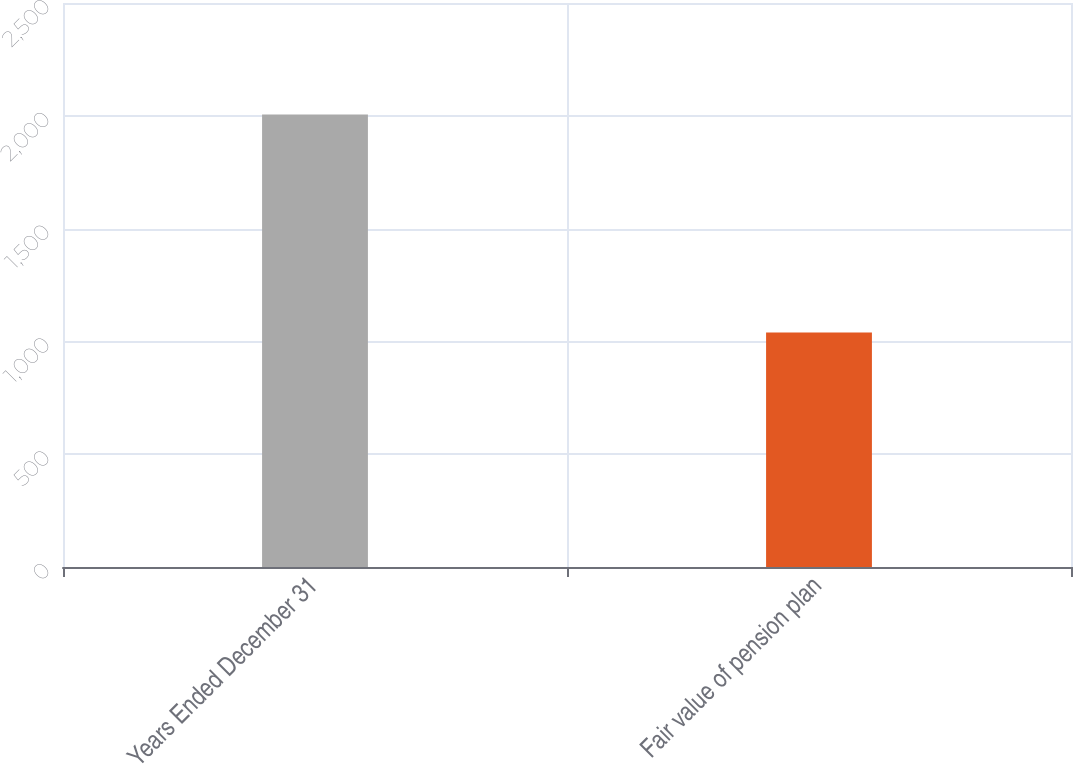<chart> <loc_0><loc_0><loc_500><loc_500><bar_chart><fcel>Years Ended December 31<fcel>Fair value of pension plan<nl><fcel>2006<fcel>1040<nl></chart> 